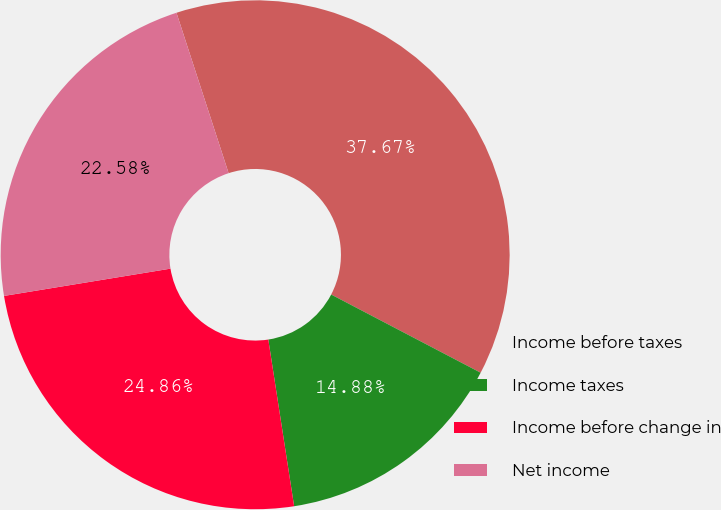Convert chart to OTSL. <chart><loc_0><loc_0><loc_500><loc_500><pie_chart><fcel>Income before taxes<fcel>Income taxes<fcel>Income before change in<fcel>Net income<nl><fcel>37.67%<fcel>14.88%<fcel>24.86%<fcel>22.58%<nl></chart> 